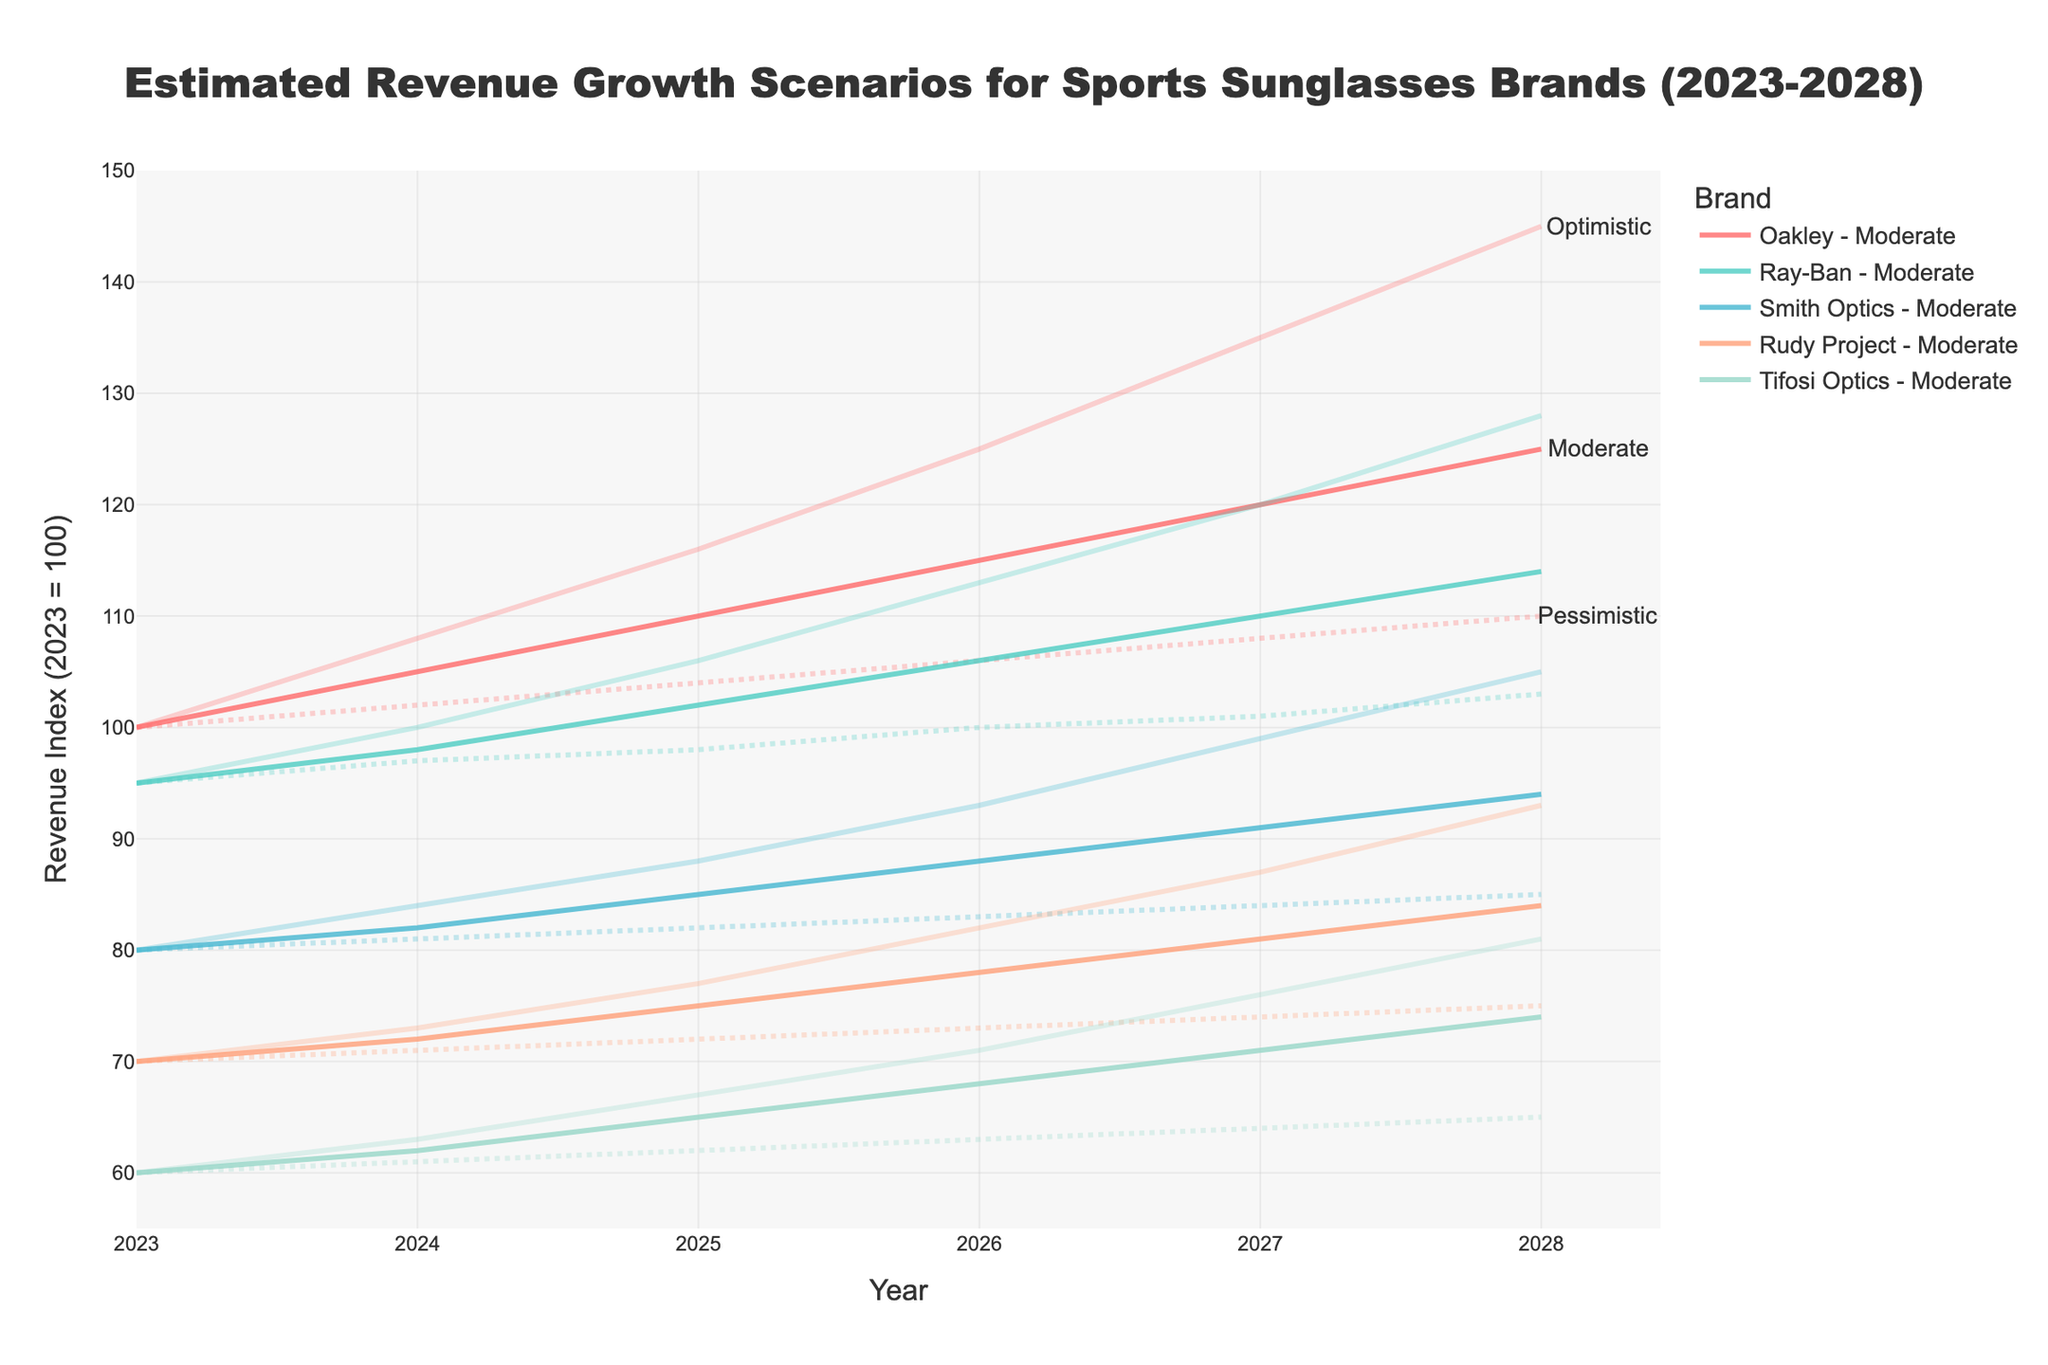What year does the estimated revenue growth scenario analysis start? The x-axis of the figure displays years ranging from 2023 to 2028. The starting year marked on the x-axis is 2023.
Answer: 2023 Which brand has the highest estimated revenue in the optimistic scenario by 2028? By following the lines labeled as "Optimistic" for each brand, the highest point in 2028 is for Oakley at 145.
Answer: Oakley How does the revenue of Rudy Project in the moderate scenario change from 2023 to 2025? In 2023, it starts at 70, and in 2025 it is projected to be 75. The change in revenue is calculated as 75 - 70 = 5.
Answer: Increases by 5 What is the difference in revenue between the optimistic and pessimistic scenarios for Tifosi Optics in 2028? The revenue for Tifosi Optics in the optimistic scenario in 2028 is 81, and for the pessimistic scenario, it is 65. The difference is calculated as 81 - 65 = 16.
Answer: 16 In what year do all brands have their values start to diverge significantly depending on the scenario? Observing the figure, the revenue lines for different scenarios start to clearly diverge around 2025.
Answer: 2025 Which brand shows the steepest increase in the optimistic scenario from 2023 to 2024? Reviewing the lines, Oakley shows an increase from 100 to 108, which is an 8-point increase. The other brands show smaller increases.
Answer: Oakley What is the overall trend for Ray-Ban's revenue in the moderate scenario from 2023 to 2028? Observing the figure, Ray-Ban's revenue shows a steady and gradual upward trend from 95 in 2023 to 114 in 2028.
Answer: Upward trend How much higher is the optimistic revenue projection for Smith Optics in 2026 compared to its moderate projection? The optimistic revenue for Smith Optics in 2026 is 93, and the moderate revenue is 88. The difference is 93 - 88 = 5.
Answer: 5 By 2027, which brand has the smallest difference between its moderate and pessimistic revenue scenarios? In 2027, Smith Optics has a moderate revenue of 91 and a pessimistic revenue of 84. The difference is 91 - 84 = 7, which is the smallest compared to other brands.
Answer: Smith Optics 